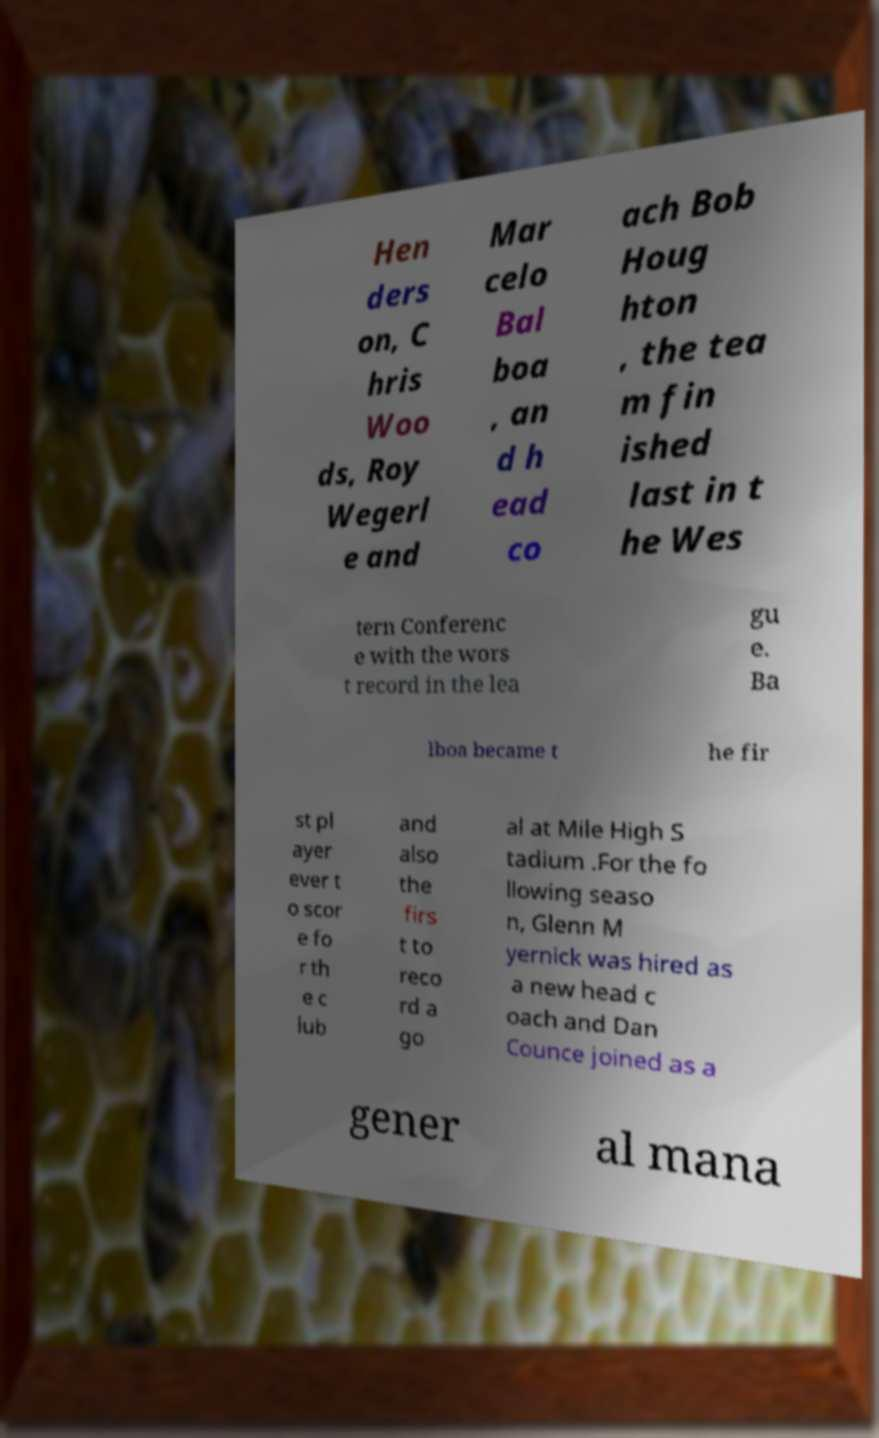I need the written content from this picture converted into text. Can you do that? Hen ders on, C hris Woo ds, Roy Wegerl e and Mar celo Bal boa , an d h ead co ach Bob Houg hton , the tea m fin ished last in t he Wes tern Conferenc e with the wors t record in the lea gu e. Ba lboa became t he fir st pl ayer ever t o scor e fo r th e c lub and also the firs t to reco rd a go al at Mile High S tadium .For the fo llowing seaso n, Glenn M yernick was hired as a new head c oach and Dan Counce joined as a gener al mana 